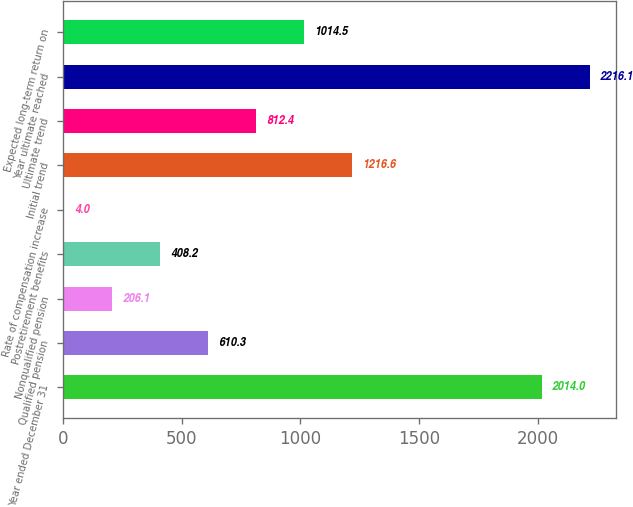Convert chart. <chart><loc_0><loc_0><loc_500><loc_500><bar_chart><fcel>Year ended December 31<fcel>Qualified pension<fcel>Nonqualified pension<fcel>Postretirement benefits<fcel>Rate of compensation increase<fcel>Initial trend<fcel>Ultimate trend<fcel>Year ultimate reached<fcel>Expected long-term return on<nl><fcel>2014<fcel>610.3<fcel>206.1<fcel>408.2<fcel>4<fcel>1216.6<fcel>812.4<fcel>2216.1<fcel>1014.5<nl></chart> 